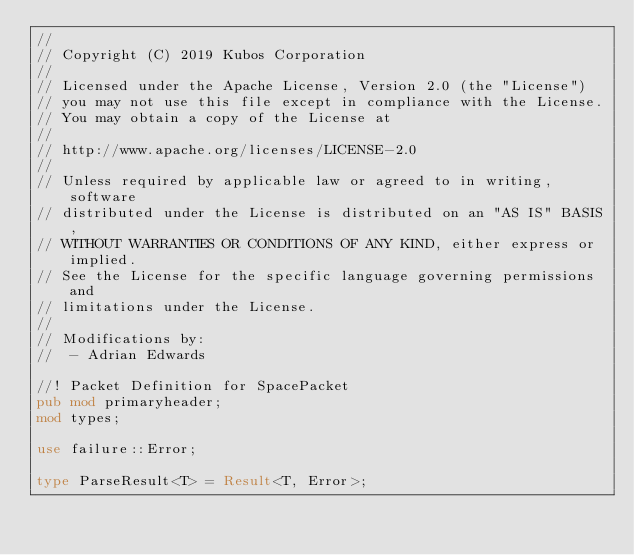Convert code to text. <code><loc_0><loc_0><loc_500><loc_500><_Rust_>//
// Copyright (C) 2019 Kubos Corporation
//
// Licensed under the Apache License, Version 2.0 (the "License")
// you may not use this file except in compliance with the License.
// You may obtain a copy of the License at
//
// http://www.apache.org/licenses/LICENSE-2.0
//
// Unless required by applicable law or agreed to in writing, software
// distributed under the License is distributed on an "AS IS" BASIS,
// WITHOUT WARRANTIES OR CONDITIONS OF ANY KIND, either express or implied.
// See the License for the specific language governing permissions and
// limitations under the License.
//
// Modifications by:
//  - Adrian Edwards

//! Packet Definition for SpacePacket
pub mod primaryheader;
mod types;

use failure::Error;

type ParseResult<T> = Result<T, Error>;
</code> 